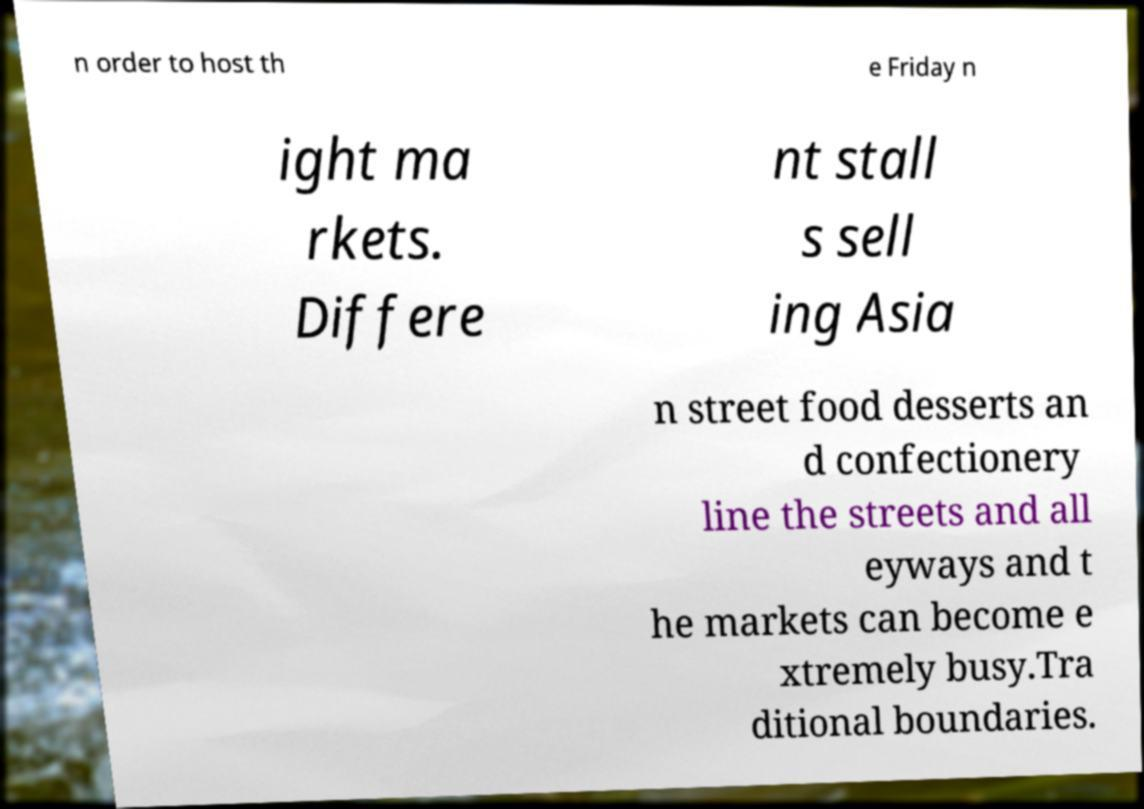I need the written content from this picture converted into text. Can you do that? n order to host th e Friday n ight ma rkets. Differe nt stall s sell ing Asia n street food desserts an d confectionery line the streets and all eyways and t he markets can become e xtremely busy.Tra ditional boundaries. 